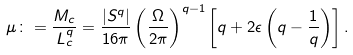<formula> <loc_0><loc_0><loc_500><loc_500>\mu \colon = \frac { M _ { c } } { L _ { c } ^ { q } } = \frac { | S ^ { q } | } { 1 6 \pi } \left ( \frac { \Omega } { 2 \pi } \right ) ^ { q - 1 } \left [ q + 2 \epsilon \left ( q - \frac { 1 } { q } \right ) \right ] .</formula> 